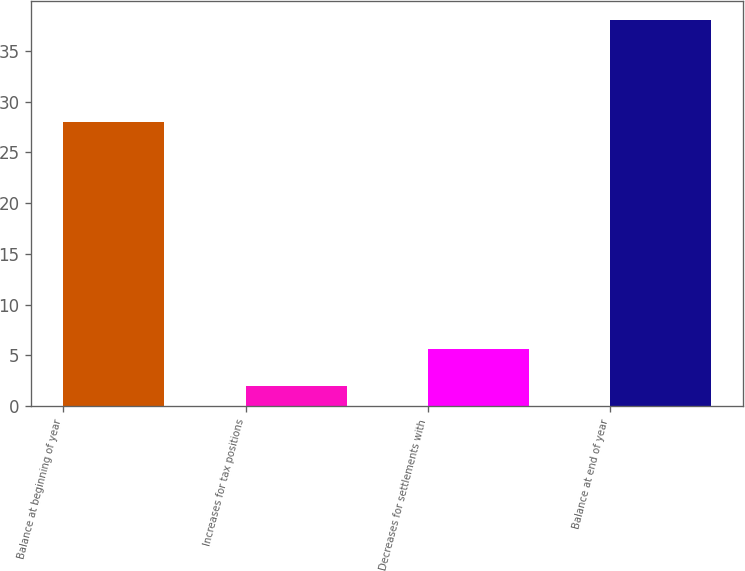Convert chart. <chart><loc_0><loc_0><loc_500><loc_500><bar_chart><fcel>Balance at beginning of year<fcel>Increases for tax positions<fcel>Decreases for settlements with<fcel>Balance at end of year<nl><fcel>28<fcel>2<fcel>5.6<fcel>38<nl></chart> 